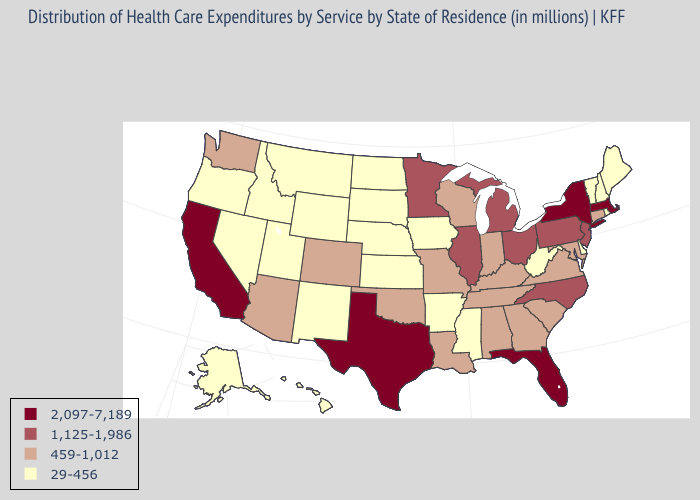Does Iowa have the highest value in the MidWest?
Answer briefly. No. What is the value of Texas?
Give a very brief answer. 2,097-7,189. Which states have the lowest value in the South?
Give a very brief answer. Arkansas, Delaware, Mississippi, West Virginia. Name the states that have a value in the range 459-1,012?
Be succinct. Alabama, Arizona, Colorado, Connecticut, Georgia, Indiana, Kentucky, Louisiana, Maryland, Missouri, Oklahoma, South Carolina, Tennessee, Virginia, Washington, Wisconsin. Among the states that border Maine , which have the highest value?
Concise answer only. New Hampshire. What is the lowest value in states that border Nebraska?
Quick response, please. 29-456. Does Kansas have a higher value than Utah?
Keep it brief. No. What is the highest value in the USA?
Answer briefly. 2,097-7,189. Does Tennessee have the lowest value in the South?
Write a very short answer. No. Among the states that border Indiana , which have the lowest value?
Give a very brief answer. Kentucky. Name the states that have a value in the range 2,097-7,189?
Keep it brief. California, Florida, Massachusetts, New York, Texas. Which states have the highest value in the USA?
Give a very brief answer. California, Florida, Massachusetts, New York, Texas. What is the value of Pennsylvania?
Be succinct. 1,125-1,986. Name the states that have a value in the range 29-456?
Quick response, please. Alaska, Arkansas, Delaware, Hawaii, Idaho, Iowa, Kansas, Maine, Mississippi, Montana, Nebraska, Nevada, New Hampshire, New Mexico, North Dakota, Oregon, Rhode Island, South Dakota, Utah, Vermont, West Virginia, Wyoming. Which states have the highest value in the USA?
Keep it brief. California, Florida, Massachusetts, New York, Texas. 